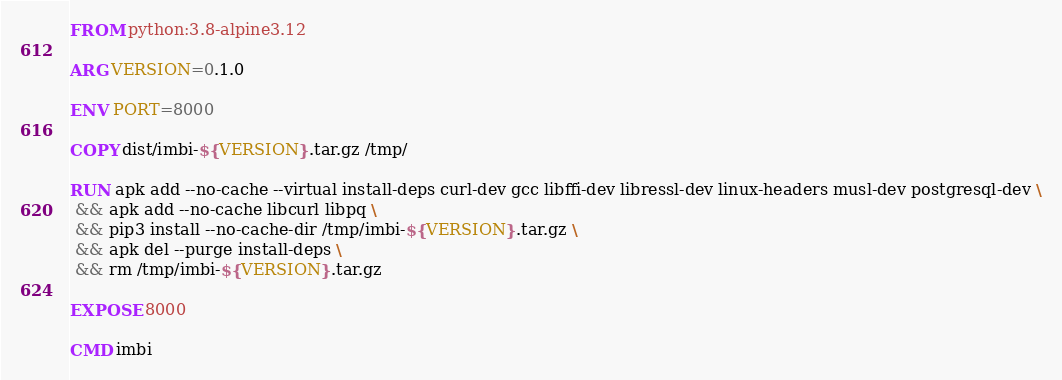<code> <loc_0><loc_0><loc_500><loc_500><_Dockerfile_>FROM python:3.8-alpine3.12

ARG VERSION=0.1.0

ENV PORT=8000

COPY dist/imbi-${VERSION}.tar.gz /tmp/

RUN apk add --no-cache --virtual install-deps curl-dev gcc libffi-dev libressl-dev linux-headers musl-dev postgresql-dev \
 && apk add --no-cache libcurl libpq \
 && pip3 install --no-cache-dir /tmp/imbi-${VERSION}.tar.gz \
 && apk del --purge install-deps \
 && rm /tmp/imbi-${VERSION}.tar.gz

EXPOSE 8000

CMD imbi
</code> 